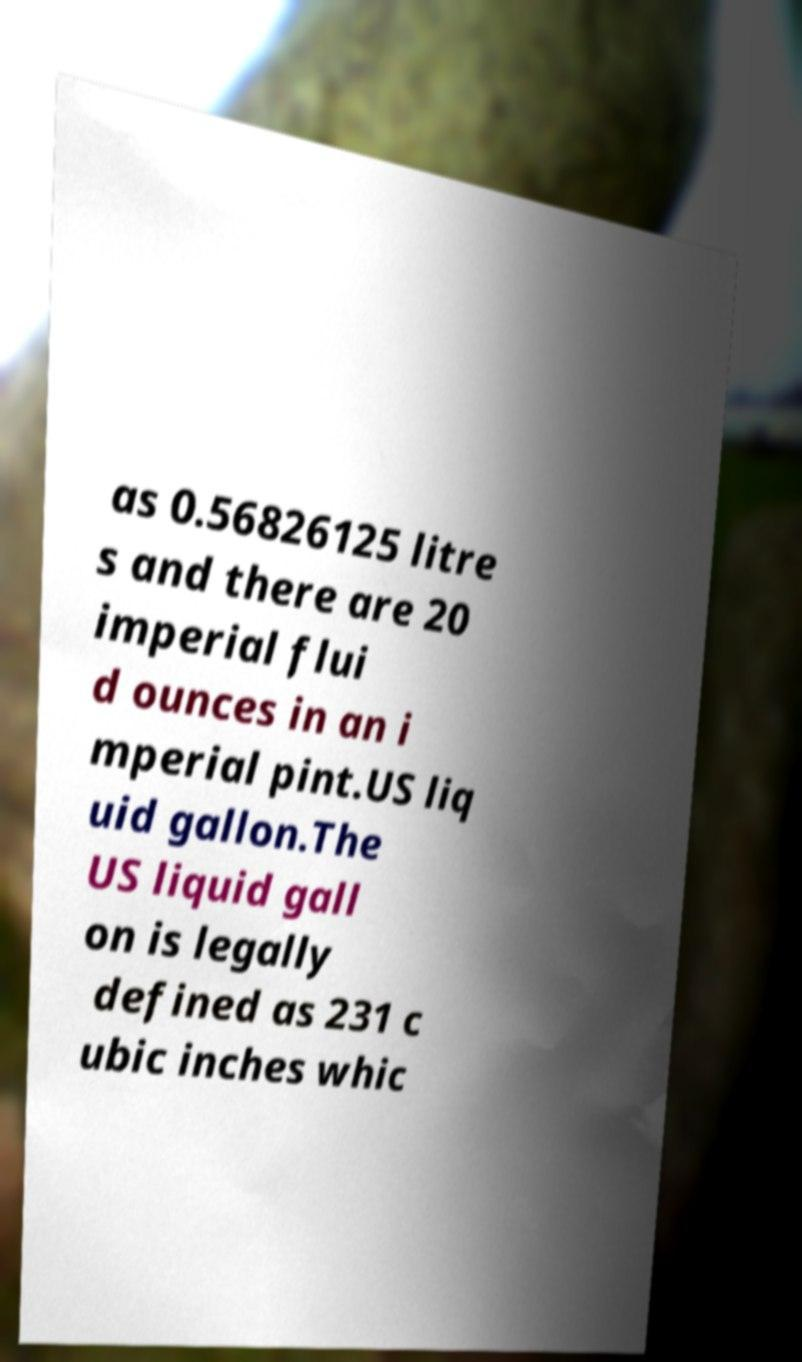There's text embedded in this image that I need extracted. Can you transcribe it verbatim? as 0.56826125 litre s and there are 20 imperial flui d ounces in an i mperial pint.US liq uid gallon.The US liquid gall on is legally defined as 231 c ubic inches whic 